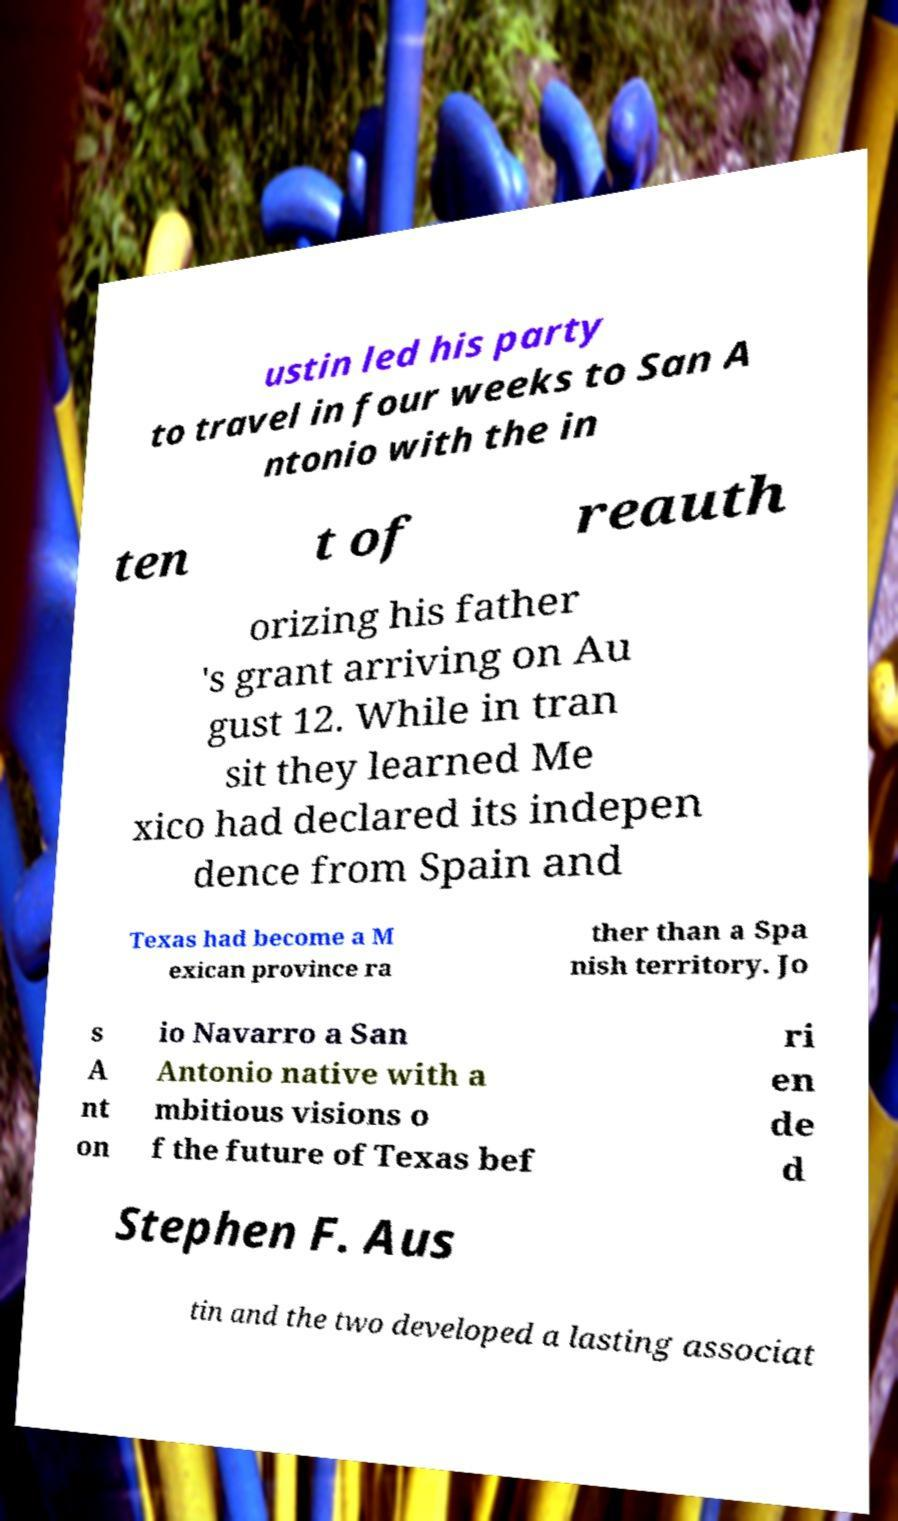Could you assist in decoding the text presented in this image and type it out clearly? ustin led his party to travel in four weeks to San A ntonio with the in ten t of reauth orizing his father 's grant arriving on Au gust 12. While in tran sit they learned Me xico had declared its indepen dence from Spain and Texas had become a M exican province ra ther than a Spa nish territory. Jo s A nt on io Navarro a San Antonio native with a mbitious visions o f the future of Texas bef ri en de d Stephen F. Aus tin and the two developed a lasting associat 